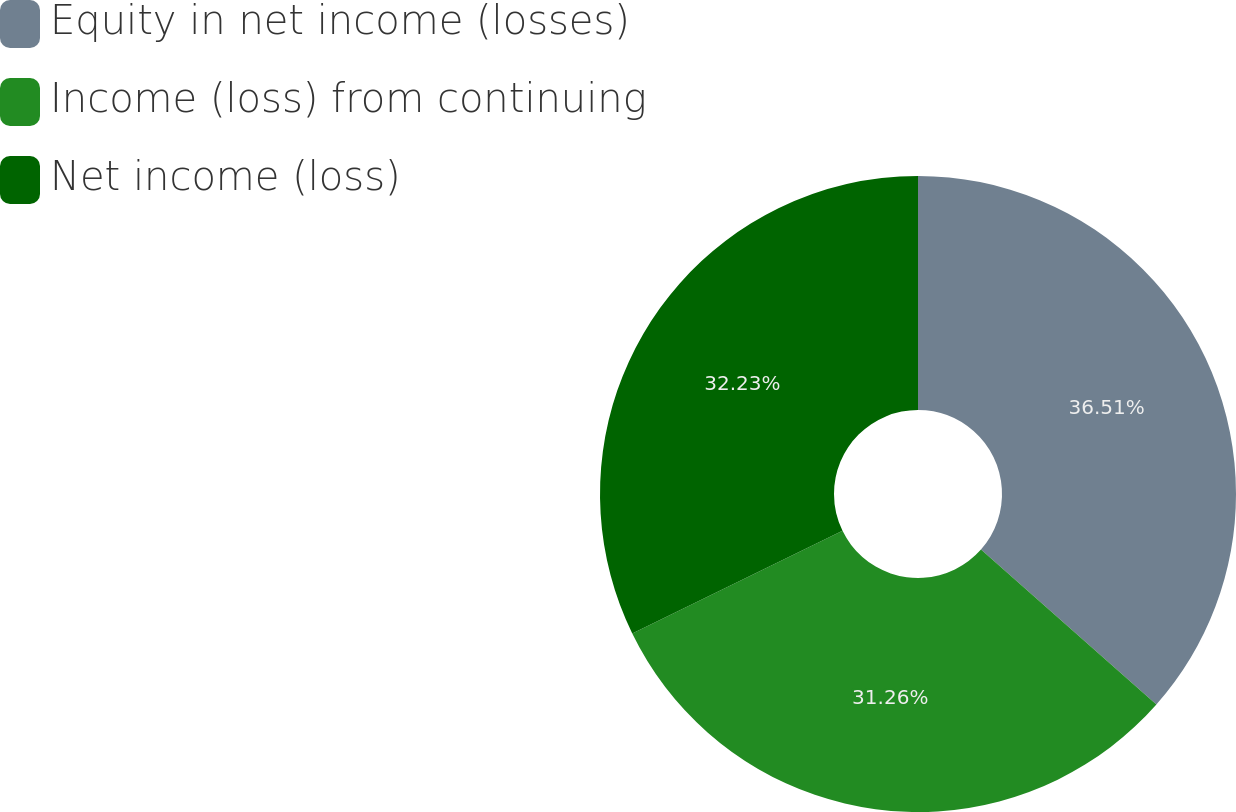<chart> <loc_0><loc_0><loc_500><loc_500><pie_chart><fcel>Equity in net income (losses)<fcel>Income (loss) from continuing<fcel>Net income (loss)<nl><fcel>36.51%<fcel>31.26%<fcel>32.23%<nl></chart> 